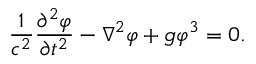<formula> <loc_0><loc_0><loc_500><loc_500>{ \frac { 1 } { c ^ { 2 } } } { \frac { \partial ^ { 2 } \varphi } { \partial t ^ { 2 } } } - \nabla ^ { 2 } \varphi + g \varphi ^ { 3 } = 0 .</formula> 